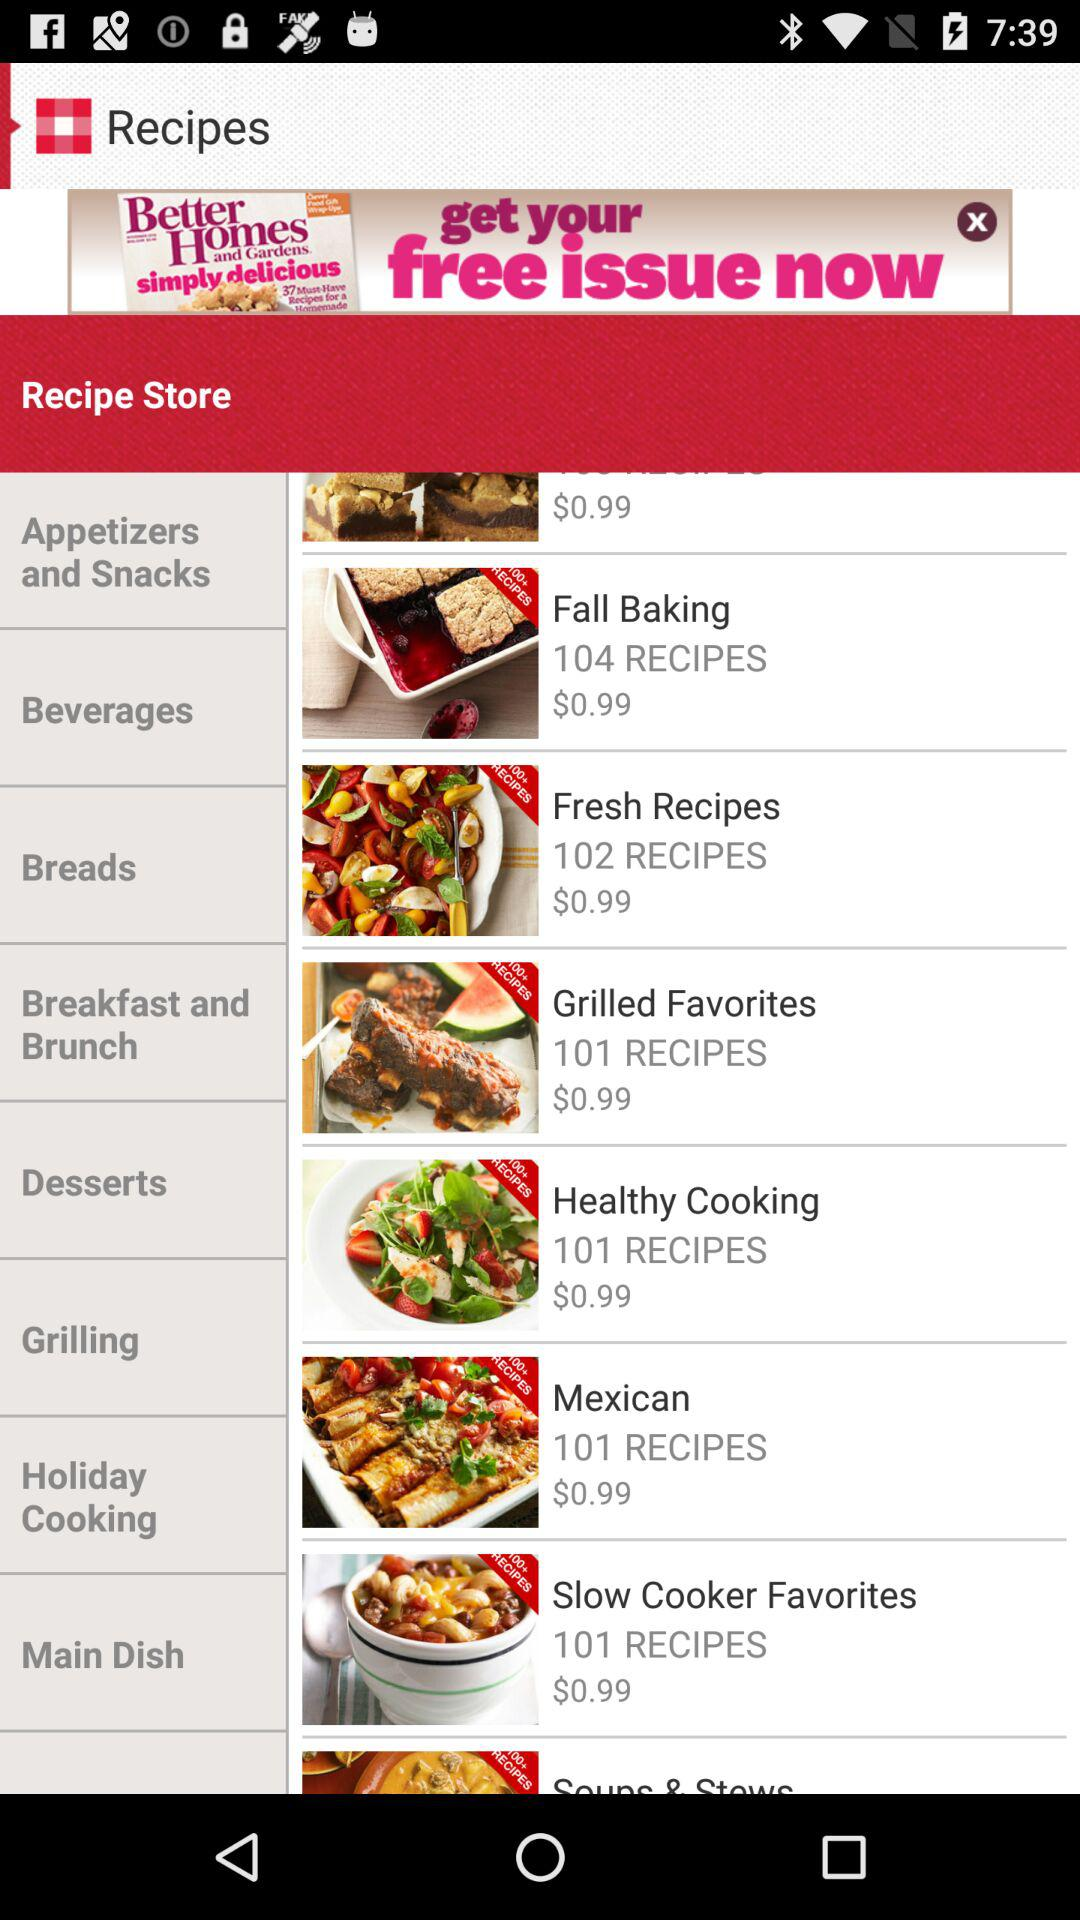How many recipes are in the Fresh Recipes section?
Answer the question using a single word or phrase. 102 